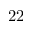Convert formula to latex. <formula><loc_0><loc_0><loc_500><loc_500>2 2</formula> 